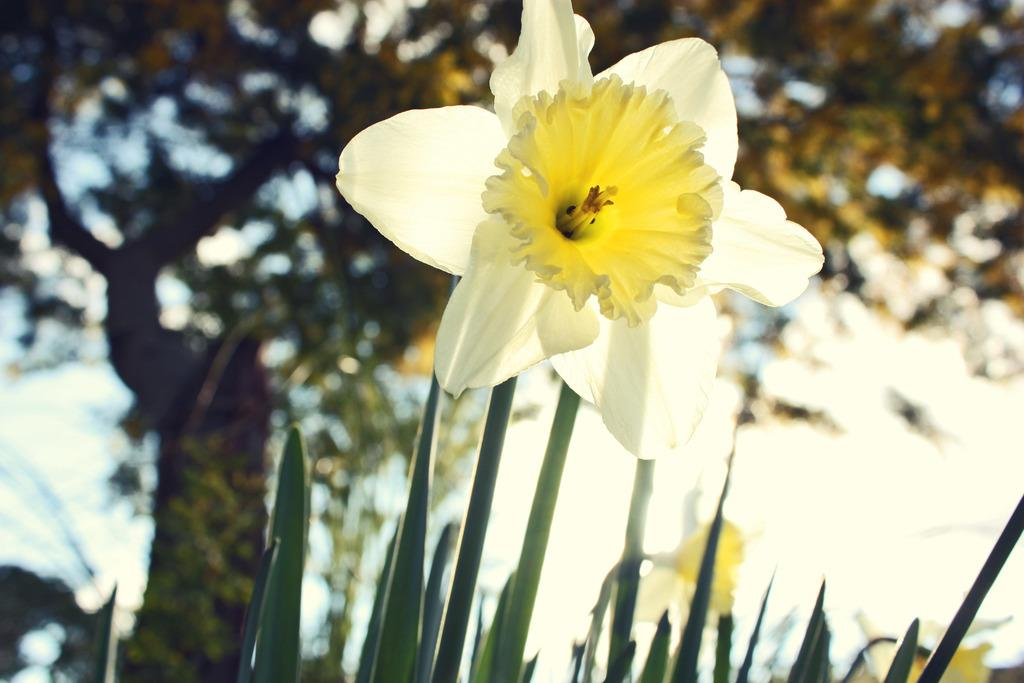What is the main subject in the foreground of the image? There is a flower in the foreground of the image. What other types of vegetation can be seen in the image? There are plants and a tree in the image. What can be seen in the background of the image? The sky is visible in the background of the image. What type of apple is being cooked on the stove in the image? There is no apple or stove present in the image; it features a flower, plants, a tree, and the sky. 